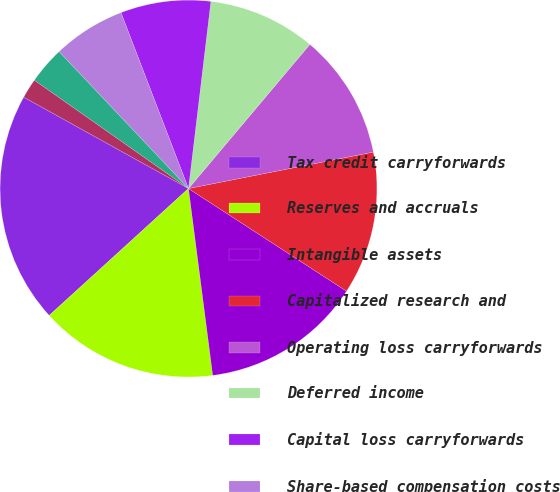Convert chart. <chart><loc_0><loc_0><loc_500><loc_500><pie_chart><fcel>Tax credit carryforwards<fcel>Reserves and accruals<fcel>Intangible assets<fcel>Capitalized research and<fcel>Operating loss carryforwards<fcel>Deferred income<fcel>Capital loss carryforwards<fcel>Share-based compensation costs<fcel>Depreciation and amortization<fcel>Investments<nl><fcel>19.82%<fcel>15.29%<fcel>13.78%<fcel>12.27%<fcel>10.76%<fcel>9.24%<fcel>7.73%<fcel>6.22%<fcel>3.2%<fcel>1.69%<nl></chart> 